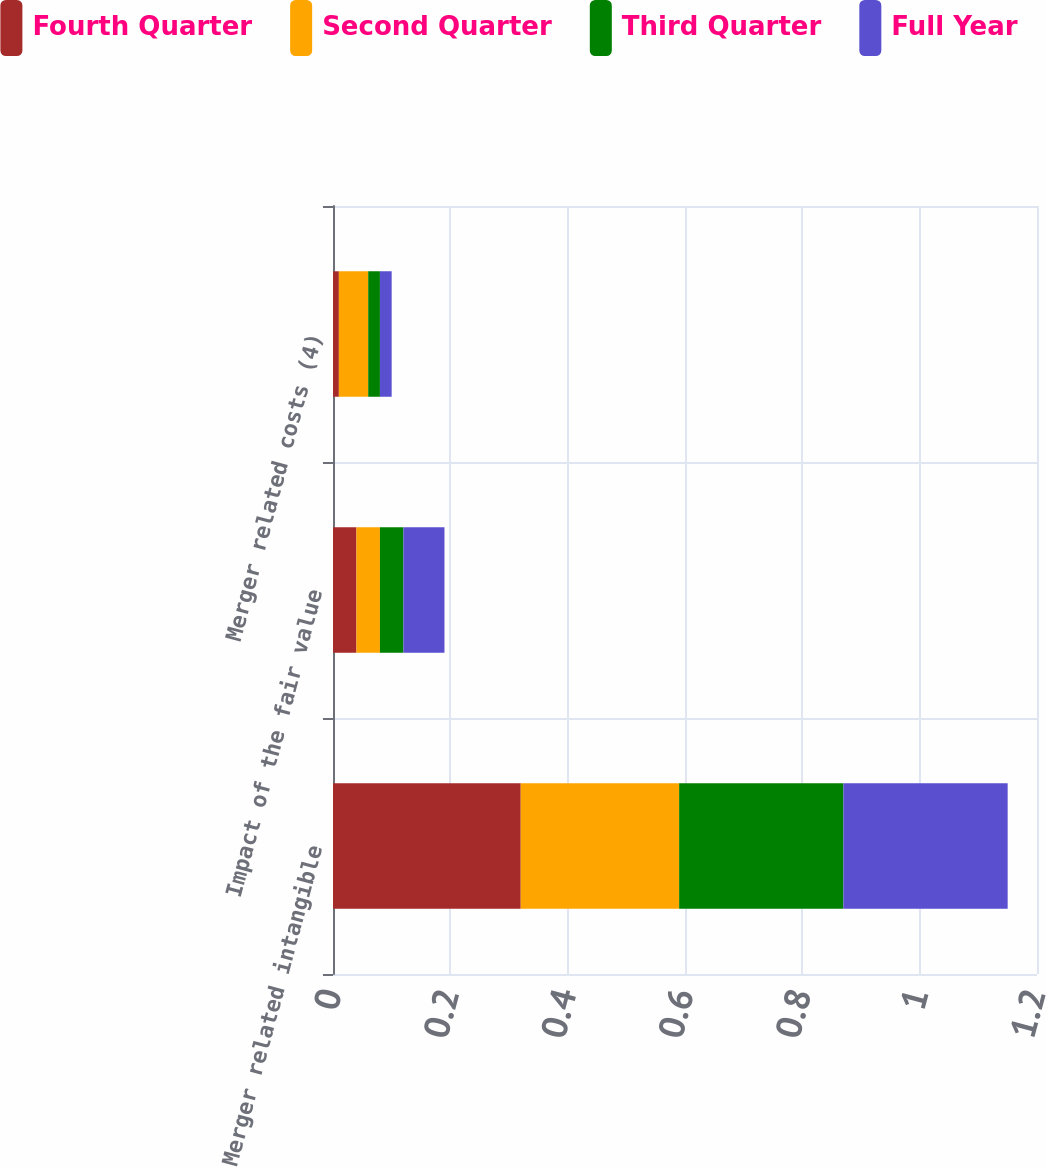Convert chart to OTSL. <chart><loc_0><loc_0><loc_500><loc_500><stacked_bar_chart><ecel><fcel>Merger related intangible<fcel>Impact of the fair value<fcel>Merger related costs (4)<nl><fcel>Fourth Quarter<fcel>0.32<fcel>0.04<fcel>0.01<nl><fcel>Second Quarter<fcel>0.27<fcel>0.04<fcel>0.05<nl><fcel>Third Quarter<fcel>0.28<fcel>0.04<fcel>0.02<nl><fcel>Full Year<fcel>0.28<fcel>0.07<fcel>0.02<nl></chart> 